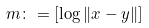<formula> <loc_0><loc_0><loc_500><loc_500>m \colon = [ \log \| x - y \| ]</formula> 